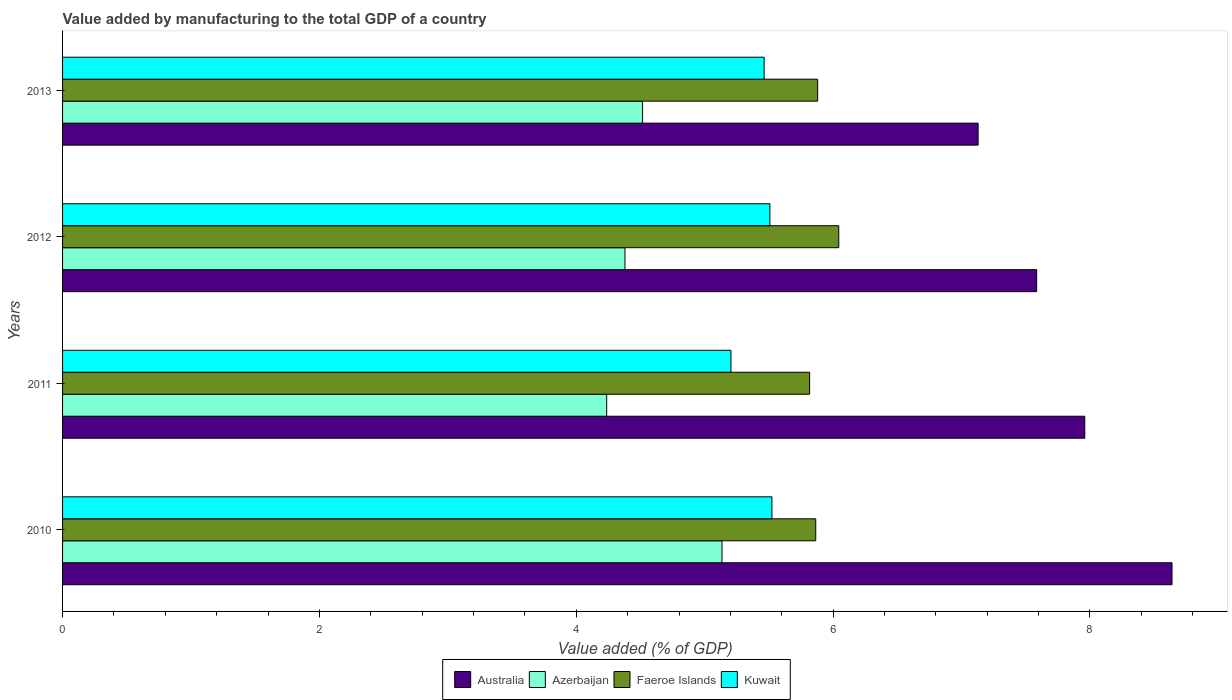How many different coloured bars are there?
Your answer should be very brief. 4. What is the label of the 2nd group of bars from the top?
Your response must be concise. 2012. In how many cases, is the number of bars for a given year not equal to the number of legend labels?
Make the answer very short. 0. What is the value added by manufacturing to the total GDP in Australia in 2012?
Your answer should be very brief. 7.58. Across all years, what is the maximum value added by manufacturing to the total GDP in Azerbaijan?
Your answer should be very brief. 5.13. Across all years, what is the minimum value added by manufacturing to the total GDP in Australia?
Offer a very short reply. 7.13. In which year was the value added by manufacturing to the total GDP in Faeroe Islands maximum?
Your answer should be compact. 2012. In which year was the value added by manufacturing to the total GDP in Australia minimum?
Provide a succinct answer. 2013. What is the total value added by manufacturing to the total GDP in Faeroe Islands in the graph?
Your response must be concise. 23.61. What is the difference between the value added by manufacturing to the total GDP in Australia in 2010 and that in 2012?
Your response must be concise. 1.05. What is the difference between the value added by manufacturing to the total GDP in Azerbaijan in 2011 and the value added by manufacturing to the total GDP in Australia in 2012?
Your answer should be compact. -3.35. What is the average value added by manufacturing to the total GDP in Kuwait per year?
Provide a short and direct response. 5.42. In the year 2012, what is the difference between the value added by manufacturing to the total GDP in Azerbaijan and value added by manufacturing to the total GDP in Kuwait?
Your answer should be very brief. -1.13. What is the ratio of the value added by manufacturing to the total GDP in Faeroe Islands in 2010 to that in 2011?
Give a very brief answer. 1.01. Is the value added by manufacturing to the total GDP in Faeroe Islands in 2010 less than that in 2011?
Your answer should be very brief. No. Is the difference between the value added by manufacturing to the total GDP in Azerbaijan in 2011 and 2013 greater than the difference between the value added by manufacturing to the total GDP in Kuwait in 2011 and 2013?
Provide a succinct answer. No. What is the difference between the highest and the second highest value added by manufacturing to the total GDP in Kuwait?
Offer a very short reply. 0.02. What is the difference between the highest and the lowest value added by manufacturing to the total GDP in Kuwait?
Provide a short and direct response. 0.32. In how many years, is the value added by manufacturing to the total GDP in Faeroe Islands greater than the average value added by manufacturing to the total GDP in Faeroe Islands taken over all years?
Ensure brevity in your answer.  1. Is it the case that in every year, the sum of the value added by manufacturing to the total GDP in Australia and value added by manufacturing to the total GDP in Kuwait is greater than the sum of value added by manufacturing to the total GDP in Azerbaijan and value added by manufacturing to the total GDP in Faeroe Islands?
Your response must be concise. Yes. What does the 1st bar from the top in 2013 represents?
Offer a very short reply. Kuwait. What does the 2nd bar from the bottom in 2010 represents?
Offer a terse response. Azerbaijan. Are all the bars in the graph horizontal?
Your response must be concise. Yes. How many years are there in the graph?
Offer a very short reply. 4. Are the values on the major ticks of X-axis written in scientific E-notation?
Your answer should be compact. No. Does the graph contain grids?
Your response must be concise. No. Where does the legend appear in the graph?
Provide a short and direct response. Bottom center. What is the title of the graph?
Your response must be concise. Value added by manufacturing to the total GDP of a country. What is the label or title of the X-axis?
Make the answer very short. Value added (% of GDP). What is the label or title of the Y-axis?
Ensure brevity in your answer.  Years. What is the Value added (% of GDP) of Australia in 2010?
Offer a terse response. 8.64. What is the Value added (% of GDP) of Azerbaijan in 2010?
Offer a terse response. 5.13. What is the Value added (% of GDP) in Faeroe Islands in 2010?
Offer a terse response. 5.86. What is the Value added (% of GDP) of Kuwait in 2010?
Offer a very short reply. 5.52. What is the Value added (% of GDP) of Australia in 2011?
Your answer should be compact. 7.96. What is the Value added (% of GDP) of Azerbaijan in 2011?
Your response must be concise. 4.24. What is the Value added (% of GDP) in Faeroe Islands in 2011?
Give a very brief answer. 5.82. What is the Value added (% of GDP) in Kuwait in 2011?
Make the answer very short. 5.2. What is the Value added (% of GDP) of Australia in 2012?
Your answer should be very brief. 7.58. What is the Value added (% of GDP) of Azerbaijan in 2012?
Ensure brevity in your answer.  4.38. What is the Value added (% of GDP) in Faeroe Islands in 2012?
Provide a succinct answer. 6.04. What is the Value added (% of GDP) in Kuwait in 2012?
Your answer should be compact. 5.51. What is the Value added (% of GDP) of Australia in 2013?
Make the answer very short. 7.13. What is the Value added (% of GDP) of Azerbaijan in 2013?
Your answer should be very brief. 4.52. What is the Value added (% of GDP) in Faeroe Islands in 2013?
Provide a short and direct response. 5.88. What is the Value added (% of GDP) of Kuwait in 2013?
Provide a succinct answer. 5.46. Across all years, what is the maximum Value added (% of GDP) in Australia?
Keep it short and to the point. 8.64. Across all years, what is the maximum Value added (% of GDP) in Azerbaijan?
Give a very brief answer. 5.13. Across all years, what is the maximum Value added (% of GDP) in Faeroe Islands?
Your response must be concise. 6.04. Across all years, what is the maximum Value added (% of GDP) in Kuwait?
Provide a short and direct response. 5.52. Across all years, what is the minimum Value added (% of GDP) in Australia?
Make the answer very short. 7.13. Across all years, what is the minimum Value added (% of GDP) of Azerbaijan?
Ensure brevity in your answer.  4.24. Across all years, what is the minimum Value added (% of GDP) of Faeroe Islands?
Provide a succinct answer. 5.82. Across all years, what is the minimum Value added (% of GDP) in Kuwait?
Give a very brief answer. 5.2. What is the total Value added (% of GDP) in Australia in the graph?
Keep it short and to the point. 31.31. What is the total Value added (% of GDP) of Azerbaijan in the graph?
Offer a very short reply. 18.27. What is the total Value added (% of GDP) of Faeroe Islands in the graph?
Your answer should be compact. 23.61. What is the total Value added (% of GDP) of Kuwait in the graph?
Give a very brief answer. 21.7. What is the difference between the Value added (% of GDP) of Australia in 2010 and that in 2011?
Offer a very short reply. 0.68. What is the difference between the Value added (% of GDP) of Azerbaijan in 2010 and that in 2011?
Your answer should be very brief. 0.9. What is the difference between the Value added (% of GDP) of Faeroe Islands in 2010 and that in 2011?
Provide a short and direct response. 0.05. What is the difference between the Value added (% of GDP) in Kuwait in 2010 and that in 2011?
Offer a very short reply. 0.32. What is the difference between the Value added (% of GDP) of Australia in 2010 and that in 2012?
Make the answer very short. 1.05. What is the difference between the Value added (% of GDP) of Azerbaijan in 2010 and that in 2012?
Your response must be concise. 0.76. What is the difference between the Value added (% of GDP) of Faeroe Islands in 2010 and that in 2012?
Provide a short and direct response. -0.18. What is the difference between the Value added (% of GDP) of Kuwait in 2010 and that in 2012?
Ensure brevity in your answer.  0.02. What is the difference between the Value added (% of GDP) of Australia in 2010 and that in 2013?
Offer a terse response. 1.51. What is the difference between the Value added (% of GDP) of Azerbaijan in 2010 and that in 2013?
Offer a terse response. 0.62. What is the difference between the Value added (% of GDP) of Faeroe Islands in 2010 and that in 2013?
Offer a very short reply. -0.01. What is the difference between the Value added (% of GDP) in Kuwait in 2010 and that in 2013?
Make the answer very short. 0.06. What is the difference between the Value added (% of GDP) of Australia in 2011 and that in 2012?
Provide a short and direct response. 0.37. What is the difference between the Value added (% of GDP) in Azerbaijan in 2011 and that in 2012?
Provide a short and direct response. -0.14. What is the difference between the Value added (% of GDP) in Faeroe Islands in 2011 and that in 2012?
Your answer should be compact. -0.23. What is the difference between the Value added (% of GDP) of Kuwait in 2011 and that in 2012?
Offer a terse response. -0.3. What is the difference between the Value added (% of GDP) of Australia in 2011 and that in 2013?
Keep it short and to the point. 0.83. What is the difference between the Value added (% of GDP) in Azerbaijan in 2011 and that in 2013?
Make the answer very short. -0.28. What is the difference between the Value added (% of GDP) in Faeroe Islands in 2011 and that in 2013?
Keep it short and to the point. -0.06. What is the difference between the Value added (% of GDP) in Kuwait in 2011 and that in 2013?
Offer a terse response. -0.26. What is the difference between the Value added (% of GDP) of Australia in 2012 and that in 2013?
Make the answer very short. 0.46. What is the difference between the Value added (% of GDP) of Azerbaijan in 2012 and that in 2013?
Your response must be concise. -0.14. What is the difference between the Value added (% of GDP) in Faeroe Islands in 2012 and that in 2013?
Provide a succinct answer. 0.16. What is the difference between the Value added (% of GDP) in Kuwait in 2012 and that in 2013?
Ensure brevity in your answer.  0.04. What is the difference between the Value added (% of GDP) of Australia in 2010 and the Value added (% of GDP) of Azerbaijan in 2011?
Your answer should be compact. 4.4. What is the difference between the Value added (% of GDP) of Australia in 2010 and the Value added (% of GDP) of Faeroe Islands in 2011?
Give a very brief answer. 2.82. What is the difference between the Value added (% of GDP) of Australia in 2010 and the Value added (% of GDP) of Kuwait in 2011?
Your answer should be compact. 3.43. What is the difference between the Value added (% of GDP) in Azerbaijan in 2010 and the Value added (% of GDP) in Faeroe Islands in 2011?
Provide a succinct answer. -0.68. What is the difference between the Value added (% of GDP) in Azerbaijan in 2010 and the Value added (% of GDP) in Kuwait in 2011?
Your answer should be compact. -0.07. What is the difference between the Value added (% of GDP) in Faeroe Islands in 2010 and the Value added (% of GDP) in Kuwait in 2011?
Give a very brief answer. 0.66. What is the difference between the Value added (% of GDP) of Australia in 2010 and the Value added (% of GDP) of Azerbaijan in 2012?
Give a very brief answer. 4.26. What is the difference between the Value added (% of GDP) of Australia in 2010 and the Value added (% of GDP) of Faeroe Islands in 2012?
Give a very brief answer. 2.6. What is the difference between the Value added (% of GDP) in Australia in 2010 and the Value added (% of GDP) in Kuwait in 2012?
Your answer should be very brief. 3.13. What is the difference between the Value added (% of GDP) in Azerbaijan in 2010 and the Value added (% of GDP) in Faeroe Islands in 2012?
Your answer should be very brief. -0.91. What is the difference between the Value added (% of GDP) in Azerbaijan in 2010 and the Value added (% of GDP) in Kuwait in 2012?
Give a very brief answer. -0.37. What is the difference between the Value added (% of GDP) in Faeroe Islands in 2010 and the Value added (% of GDP) in Kuwait in 2012?
Make the answer very short. 0.36. What is the difference between the Value added (% of GDP) in Australia in 2010 and the Value added (% of GDP) in Azerbaijan in 2013?
Provide a short and direct response. 4.12. What is the difference between the Value added (% of GDP) of Australia in 2010 and the Value added (% of GDP) of Faeroe Islands in 2013?
Your answer should be compact. 2.76. What is the difference between the Value added (% of GDP) of Australia in 2010 and the Value added (% of GDP) of Kuwait in 2013?
Your response must be concise. 3.18. What is the difference between the Value added (% of GDP) of Azerbaijan in 2010 and the Value added (% of GDP) of Faeroe Islands in 2013?
Offer a very short reply. -0.74. What is the difference between the Value added (% of GDP) in Azerbaijan in 2010 and the Value added (% of GDP) in Kuwait in 2013?
Offer a very short reply. -0.33. What is the difference between the Value added (% of GDP) in Faeroe Islands in 2010 and the Value added (% of GDP) in Kuwait in 2013?
Ensure brevity in your answer.  0.4. What is the difference between the Value added (% of GDP) of Australia in 2011 and the Value added (% of GDP) of Azerbaijan in 2012?
Provide a short and direct response. 3.58. What is the difference between the Value added (% of GDP) of Australia in 2011 and the Value added (% of GDP) of Faeroe Islands in 2012?
Offer a very short reply. 1.92. What is the difference between the Value added (% of GDP) in Australia in 2011 and the Value added (% of GDP) in Kuwait in 2012?
Make the answer very short. 2.45. What is the difference between the Value added (% of GDP) in Azerbaijan in 2011 and the Value added (% of GDP) in Faeroe Islands in 2012?
Make the answer very short. -1.81. What is the difference between the Value added (% of GDP) in Azerbaijan in 2011 and the Value added (% of GDP) in Kuwait in 2012?
Offer a terse response. -1.27. What is the difference between the Value added (% of GDP) in Faeroe Islands in 2011 and the Value added (% of GDP) in Kuwait in 2012?
Your response must be concise. 0.31. What is the difference between the Value added (% of GDP) in Australia in 2011 and the Value added (% of GDP) in Azerbaijan in 2013?
Offer a very short reply. 3.44. What is the difference between the Value added (% of GDP) in Australia in 2011 and the Value added (% of GDP) in Faeroe Islands in 2013?
Keep it short and to the point. 2.08. What is the difference between the Value added (% of GDP) in Australia in 2011 and the Value added (% of GDP) in Kuwait in 2013?
Offer a very short reply. 2.5. What is the difference between the Value added (% of GDP) of Azerbaijan in 2011 and the Value added (% of GDP) of Faeroe Islands in 2013?
Your answer should be very brief. -1.64. What is the difference between the Value added (% of GDP) in Azerbaijan in 2011 and the Value added (% of GDP) in Kuwait in 2013?
Provide a short and direct response. -1.23. What is the difference between the Value added (% of GDP) in Faeroe Islands in 2011 and the Value added (% of GDP) in Kuwait in 2013?
Provide a short and direct response. 0.35. What is the difference between the Value added (% of GDP) of Australia in 2012 and the Value added (% of GDP) of Azerbaijan in 2013?
Your response must be concise. 3.07. What is the difference between the Value added (% of GDP) of Australia in 2012 and the Value added (% of GDP) of Faeroe Islands in 2013?
Your answer should be very brief. 1.71. What is the difference between the Value added (% of GDP) of Australia in 2012 and the Value added (% of GDP) of Kuwait in 2013?
Provide a succinct answer. 2.12. What is the difference between the Value added (% of GDP) of Azerbaijan in 2012 and the Value added (% of GDP) of Faeroe Islands in 2013?
Offer a very short reply. -1.5. What is the difference between the Value added (% of GDP) in Azerbaijan in 2012 and the Value added (% of GDP) in Kuwait in 2013?
Make the answer very short. -1.08. What is the difference between the Value added (% of GDP) in Faeroe Islands in 2012 and the Value added (% of GDP) in Kuwait in 2013?
Ensure brevity in your answer.  0.58. What is the average Value added (% of GDP) of Australia per year?
Make the answer very short. 7.83. What is the average Value added (% of GDP) in Azerbaijan per year?
Ensure brevity in your answer.  4.57. What is the average Value added (% of GDP) of Faeroe Islands per year?
Your answer should be compact. 5.9. What is the average Value added (% of GDP) of Kuwait per year?
Keep it short and to the point. 5.42. In the year 2010, what is the difference between the Value added (% of GDP) of Australia and Value added (% of GDP) of Azerbaijan?
Offer a very short reply. 3.5. In the year 2010, what is the difference between the Value added (% of GDP) of Australia and Value added (% of GDP) of Faeroe Islands?
Give a very brief answer. 2.77. In the year 2010, what is the difference between the Value added (% of GDP) in Australia and Value added (% of GDP) in Kuwait?
Give a very brief answer. 3.12. In the year 2010, what is the difference between the Value added (% of GDP) of Azerbaijan and Value added (% of GDP) of Faeroe Islands?
Your answer should be compact. -0.73. In the year 2010, what is the difference between the Value added (% of GDP) in Azerbaijan and Value added (% of GDP) in Kuwait?
Your response must be concise. -0.39. In the year 2010, what is the difference between the Value added (% of GDP) in Faeroe Islands and Value added (% of GDP) in Kuwait?
Your response must be concise. 0.34. In the year 2011, what is the difference between the Value added (% of GDP) in Australia and Value added (% of GDP) in Azerbaijan?
Keep it short and to the point. 3.72. In the year 2011, what is the difference between the Value added (% of GDP) in Australia and Value added (% of GDP) in Faeroe Islands?
Give a very brief answer. 2.14. In the year 2011, what is the difference between the Value added (% of GDP) in Australia and Value added (% of GDP) in Kuwait?
Make the answer very short. 2.76. In the year 2011, what is the difference between the Value added (% of GDP) of Azerbaijan and Value added (% of GDP) of Faeroe Islands?
Offer a terse response. -1.58. In the year 2011, what is the difference between the Value added (% of GDP) of Azerbaijan and Value added (% of GDP) of Kuwait?
Ensure brevity in your answer.  -0.97. In the year 2011, what is the difference between the Value added (% of GDP) of Faeroe Islands and Value added (% of GDP) of Kuwait?
Make the answer very short. 0.61. In the year 2012, what is the difference between the Value added (% of GDP) of Australia and Value added (% of GDP) of Azerbaijan?
Provide a succinct answer. 3.21. In the year 2012, what is the difference between the Value added (% of GDP) of Australia and Value added (% of GDP) of Faeroe Islands?
Provide a succinct answer. 1.54. In the year 2012, what is the difference between the Value added (% of GDP) in Australia and Value added (% of GDP) in Kuwait?
Offer a terse response. 2.08. In the year 2012, what is the difference between the Value added (% of GDP) of Azerbaijan and Value added (% of GDP) of Faeroe Islands?
Make the answer very short. -1.66. In the year 2012, what is the difference between the Value added (% of GDP) of Azerbaijan and Value added (% of GDP) of Kuwait?
Your response must be concise. -1.13. In the year 2012, what is the difference between the Value added (% of GDP) in Faeroe Islands and Value added (% of GDP) in Kuwait?
Offer a very short reply. 0.54. In the year 2013, what is the difference between the Value added (% of GDP) of Australia and Value added (% of GDP) of Azerbaijan?
Ensure brevity in your answer.  2.61. In the year 2013, what is the difference between the Value added (% of GDP) in Australia and Value added (% of GDP) in Faeroe Islands?
Offer a terse response. 1.25. In the year 2013, what is the difference between the Value added (% of GDP) in Australia and Value added (% of GDP) in Kuwait?
Provide a succinct answer. 1.67. In the year 2013, what is the difference between the Value added (% of GDP) in Azerbaijan and Value added (% of GDP) in Faeroe Islands?
Ensure brevity in your answer.  -1.36. In the year 2013, what is the difference between the Value added (% of GDP) in Azerbaijan and Value added (% of GDP) in Kuwait?
Provide a short and direct response. -0.95. In the year 2013, what is the difference between the Value added (% of GDP) in Faeroe Islands and Value added (% of GDP) in Kuwait?
Provide a succinct answer. 0.42. What is the ratio of the Value added (% of GDP) of Australia in 2010 to that in 2011?
Ensure brevity in your answer.  1.09. What is the ratio of the Value added (% of GDP) in Azerbaijan in 2010 to that in 2011?
Ensure brevity in your answer.  1.21. What is the ratio of the Value added (% of GDP) in Faeroe Islands in 2010 to that in 2011?
Your answer should be compact. 1.01. What is the ratio of the Value added (% of GDP) in Kuwait in 2010 to that in 2011?
Your response must be concise. 1.06. What is the ratio of the Value added (% of GDP) in Australia in 2010 to that in 2012?
Provide a short and direct response. 1.14. What is the ratio of the Value added (% of GDP) in Azerbaijan in 2010 to that in 2012?
Provide a short and direct response. 1.17. What is the ratio of the Value added (% of GDP) of Faeroe Islands in 2010 to that in 2012?
Your response must be concise. 0.97. What is the ratio of the Value added (% of GDP) of Kuwait in 2010 to that in 2012?
Your response must be concise. 1. What is the ratio of the Value added (% of GDP) of Australia in 2010 to that in 2013?
Ensure brevity in your answer.  1.21. What is the ratio of the Value added (% of GDP) in Azerbaijan in 2010 to that in 2013?
Ensure brevity in your answer.  1.14. What is the ratio of the Value added (% of GDP) of Faeroe Islands in 2010 to that in 2013?
Make the answer very short. 1. What is the ratio of the Value added (% of GDP) of Kuwait in 2010 to that in 2013?
Give a very brief answer. 1.01. What is the ratio of the Value added (% of GDP) of Australia in 2011 to that in 2012?
Your answer should be very brief. 1.05. What is the ratio of the Value added (% of GDP) of Azerbaijan in 2011 to that in 2012?
Offer a terse response. 0.97. What is the ratio of the Value added (% of GDP) in Faeroe Islands in 2011 to that in 2012?
Your answer should be compact. 0.96. What is the ratio of the Value added (% of GDP) in Kuwait in 2011 to that in 2012?
Keep it short and to the point. 0.94. What is the ratio of the Value added (% of GDP) of Australia in 2011 to that in 2013?
Provide a short and direct response. 1.12. What is the ratio of the Value added (% of GDP) in Azerbaijan in 2011 to that in 2013?
Make the answer very short. 0.94. What is the ratio of the Value added (% of GDP) of Kuwait in 2011 to that in 2013?
Ensure brevity in your answer.  0.95. What is the ratio of the Value added (% of GDP) of Australia in 2012 to that in 2013?
Provide a succinct answer. 1.06. What is the ratio of the Value added (% of GDP) in Azerbaijan in 2012 to that in 2013?
Your answer should be compact. 0.97. What is the ratio of the Value added (% of GDP) in Faeroe Islands in 2012 to that in 2013?
Offer a very short reply. 1.03. What is the ratio of the Value added (% of GDP) in Kuwait in 2012 to that in 2013?
Offer a very short reply. 1.01. What is the difference between the highest and the second highest Value added (% of GDP) in Australia?
Offer a very short reply. 0.68. What is the difference between the highest and the second highest Value added (% of GDP) of Azerbaijan?
Provide a short and direct response. 0.62. What is the difference between the highest and the second highest Value added (% of GDP) of Faeroe Islands?
Your answer should be very brief. 0.16. What is the difference between the highest and the second highest Value added (% of GDP) in Kuwait?
Provide a short and direct response. 0.02. What is the difference between the highest and the lowest Value added (% of GDP) of Australia?
Your response must be concise. 1.51. What is the difference between the highest and the lowest Value added (% of GDP) of Azerbaijan?
Provide a short and direct response. 0.9. What is the difference between the highest and the lowest Value added (% of GDP) in Faeroe Islands?
Offer a terse response. 0.23. What is the difference between the highest and the lowest Value added (% of GDP) in Kuwait?
Give a very brief answer. 0.32. 